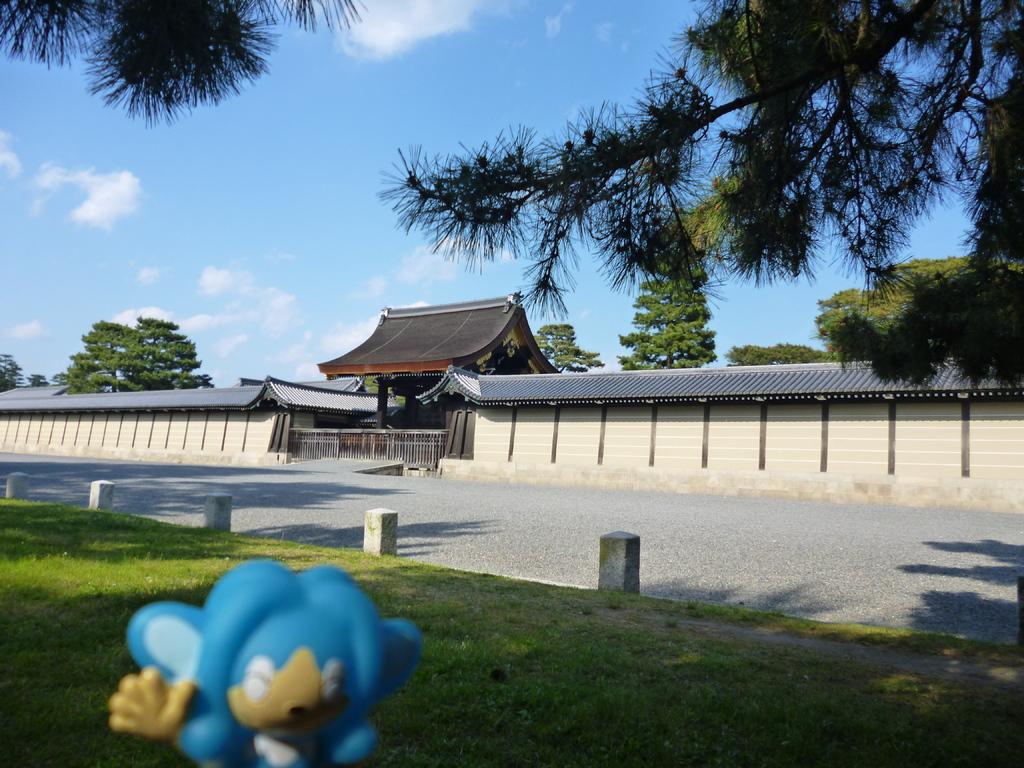Please provide a concise description of this image. In this image there is grass. There is a blue color object in the foreground. There is a road. There is a building. There is a wall. There are trees. There are clouds in the sky. 